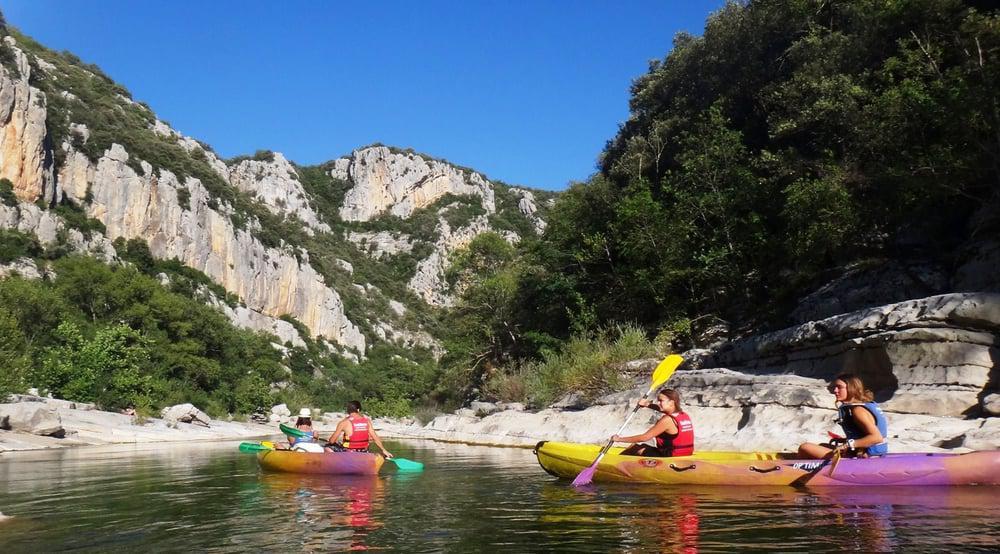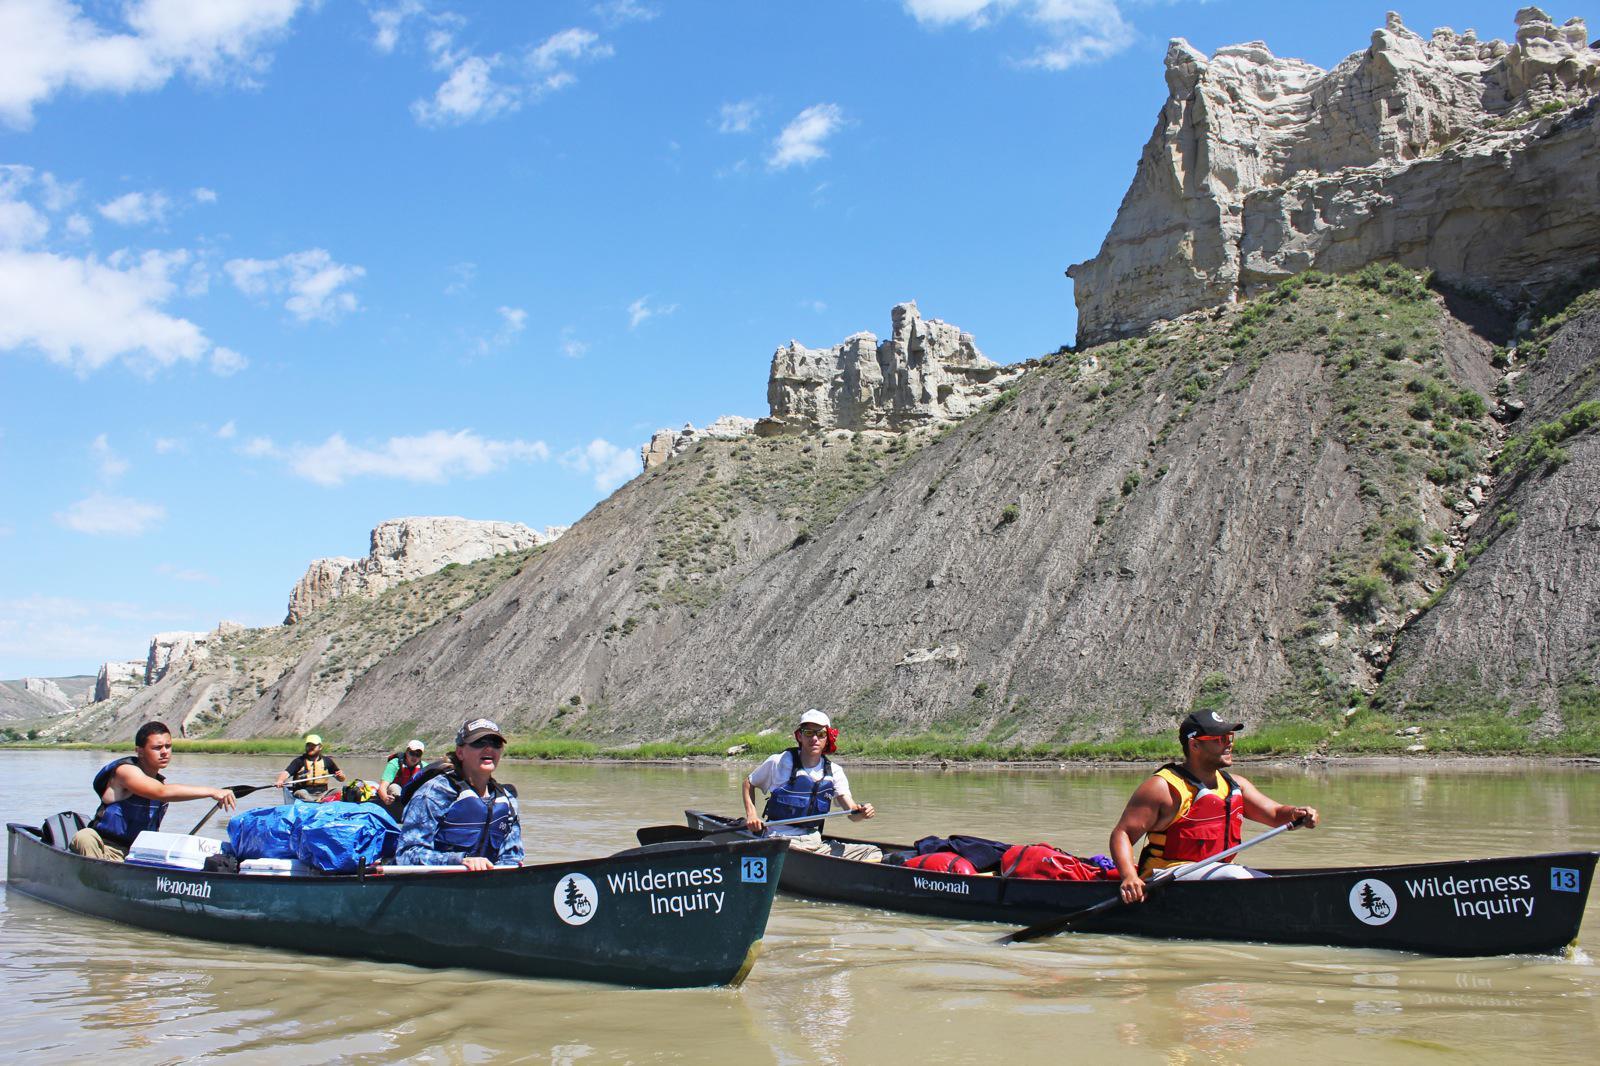The first image is the image on the left, the second image is the image on the right. Analyze the images presented: Is the assertion "There are two people riding a single canoe in the lefthand image." valid? Answer yes or no. No. The first image is the image on the left, the second image is the image on the right. Examine the images to the left and right. Is the description "at least one boat has an oar touching the water surface in the image pair" accurate? Answer yes or no. Yes. 